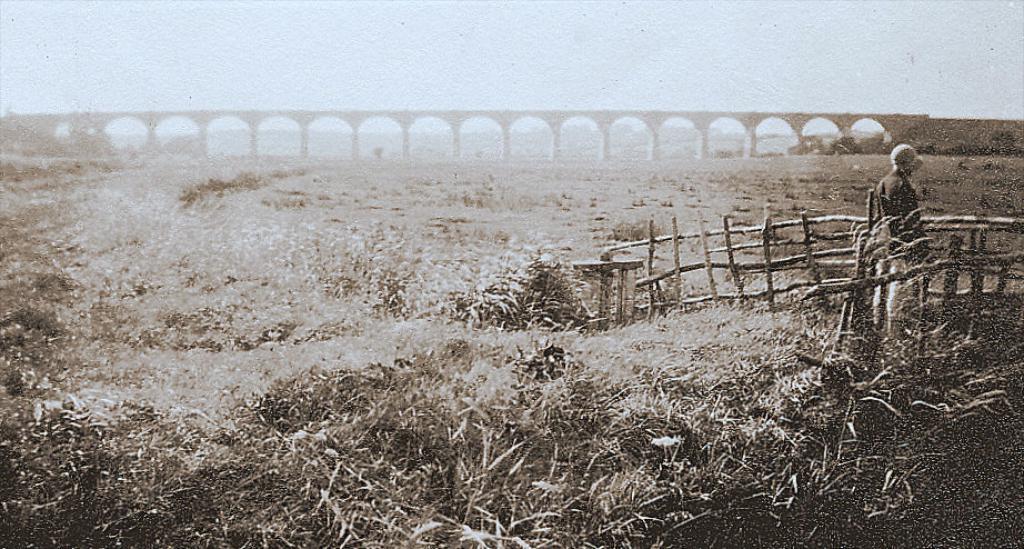Can you describe this image briefly? In this image I can see an open grass ground and on the right side of the image I can see one person is standing. I can also see wooden fencing on the right side and in the background I can see a bridge and the sky. 